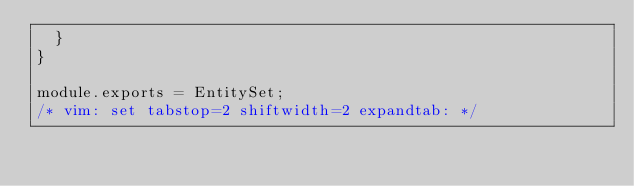<code> <loc_0><loc_0><loc_500><loc_500><_JavaScript_>  }
}

module.exports = EntitySet;
/* vim: set tabstop=2 shiftwidth=2 expandtab: */
</code> 